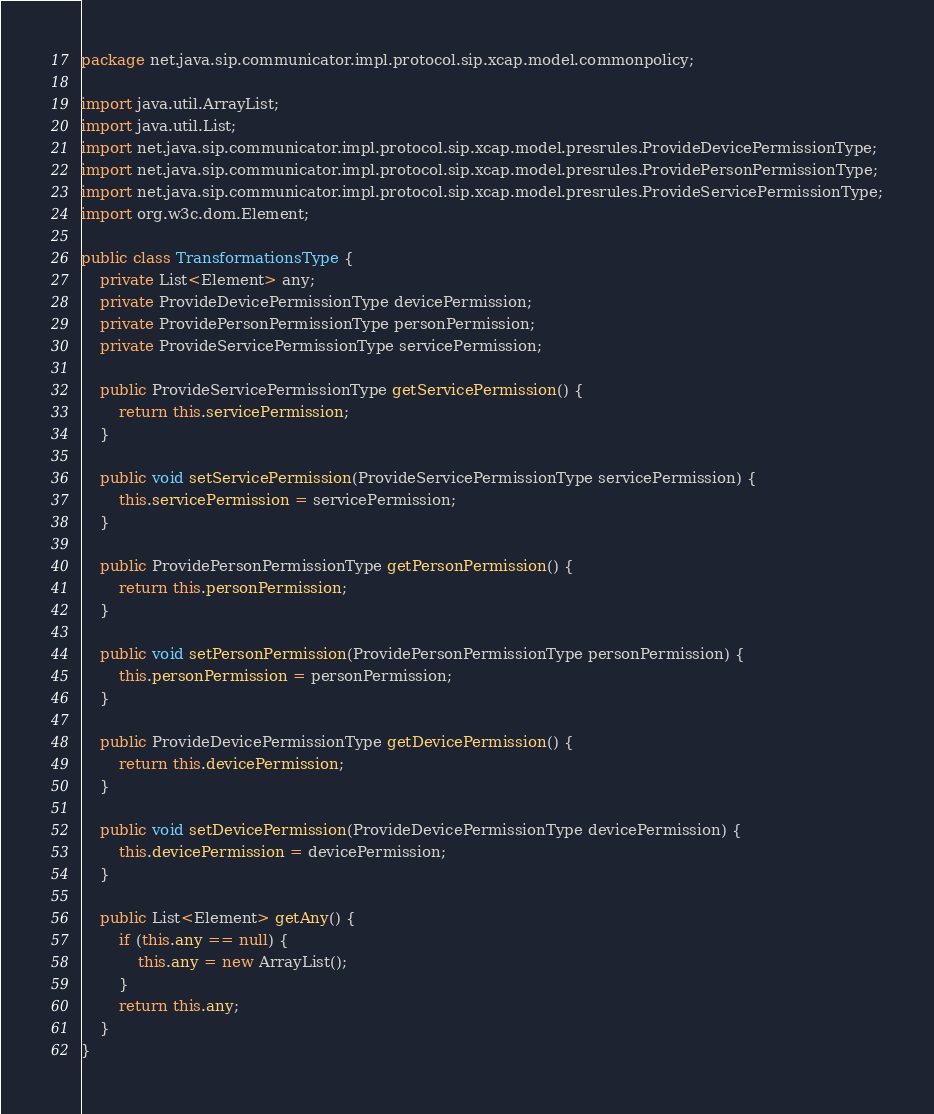Convert code to text. <code><loc_0><loc_0><loc_500><loc_500><_Java_>package net.java.sip.communicator.impl.protocol.sip.xcap.model.commonpolicy;

import java.util.ArrayList;
import java.util.List;
import net.java.sip.communicator.impl.protocol.sip.xcap.model.presrules.ProvideDevicePermissionType;
import net.java.sip.communicator.impl.protocol.sip.xcap.model.presrules.ProvidePersonPermissionType;
import net.java.sip.communicator.impl.protocol.sip.xcap.model.presrules.ProvideServicePermissionType;
import org.w3c.dom.Element;

public class TransformationsType {
    private List<Element> any;
    private ProvideDevicePermissionType devicePermission;
    private ProvidePersonPermissionType personPermission;
    private ProvideServicePermissionType servicePermission;

    public ProvideServicePermissionType getServicePermission() {
        return this.servicePermission;
    }

    public void setServicePermission(ProvideServicePermissionType servicePermission) {
        this.servicePermission = servicePermission;
    }

    public ProvidePersonPermissionType getPersonPermission() {
        return this.personPermission;
    }

    public void setPersonPermission(ProvidePersonPermissionType personPermission) {
        this.personPermission = personPermission;
    }

    public ProvideDevicePermissionType getDevicePermission() {
        return this.devicePermission;
    }

    public void setDevicePermission(ProvideDevicePermissionType devicePermission) {
        this.devicePermission = devicePermission;
    }

    public List<Element> getAny() {
        if (this.any == null) {
            this.any = new ArrayList();
        }
        return this.any;
    }
}
</code> 